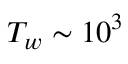Convert formula to latex. <formula><loc_0><loc_0><loc_500><loc_500>T _ { w } \sim 1 0 ^ { 3 }</formula> 